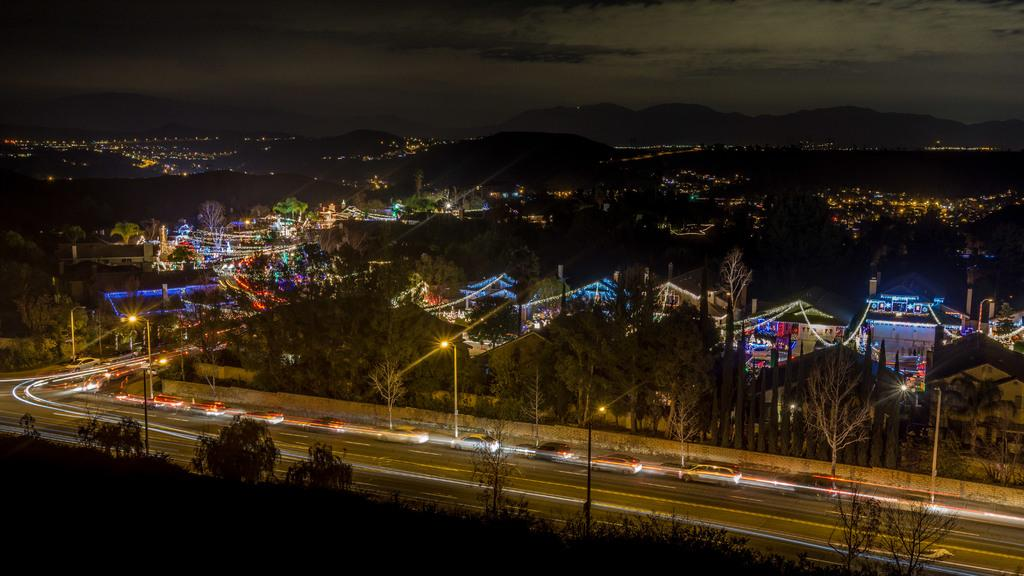What type of location is depicted in the image? The image shows a view of a city. What natural elements can be seen in the image? There are trees in the image. What artificial elements can be seen in the image? There are lights, houses, and vehicles on the road in the image. What geographical features are present in the image? There are hills in the image. What part of the natural environment is visible in the image? The sky is visible in the background of the image. What type of butter is being used in the hospital depicted in the image? There is no hospital or butter present in the image; it shows a view of a city with trees, lights, houses, hills, vehicles, and a visible sky. 